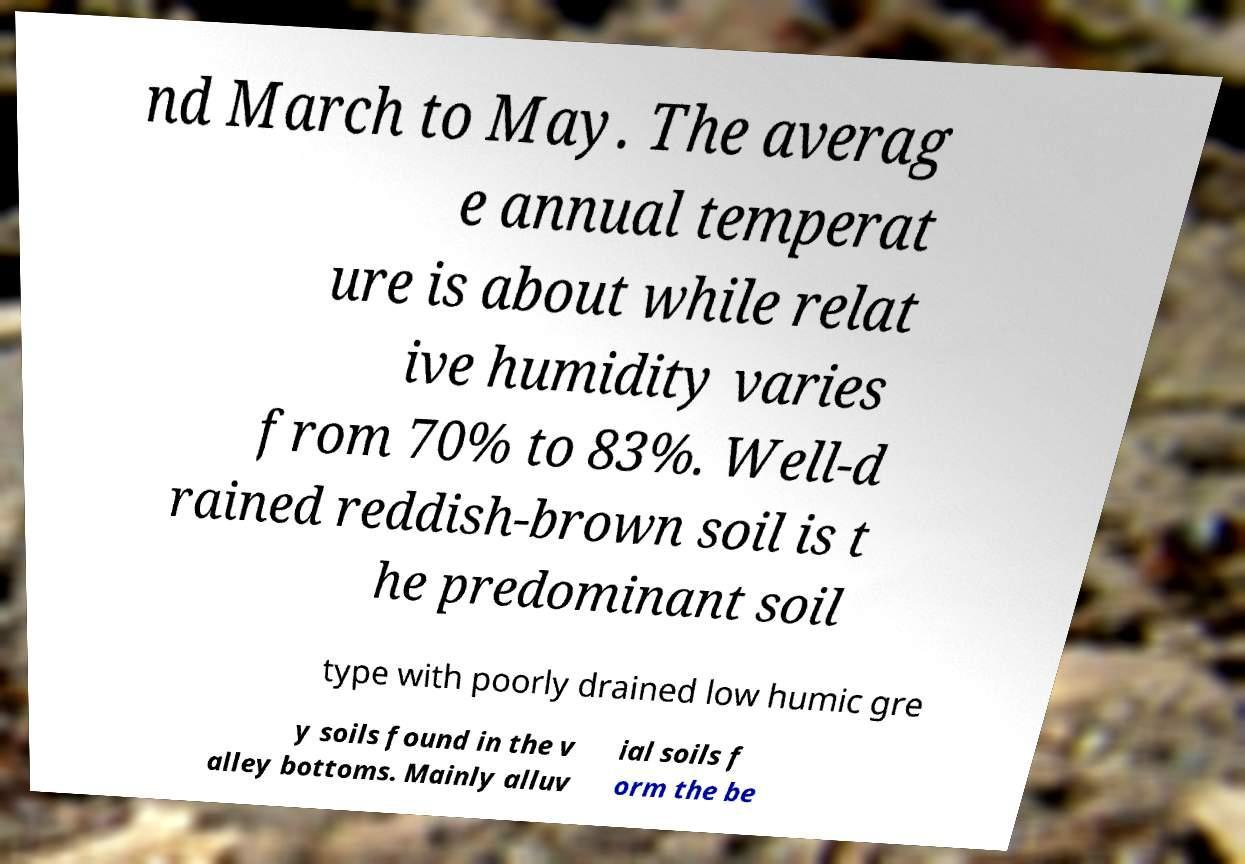Can you accurately transcribe the text from the provided image for me? nd March to May. The averag e annual temperat ure is about while relat ive humidity varies from 70% to 83%. Well-d rained reddish-brown soil is t he predominant soil type with poorly drained low humic gre y soils found in the v alley bottoms. Mainly alluv ial soils f orm the be 